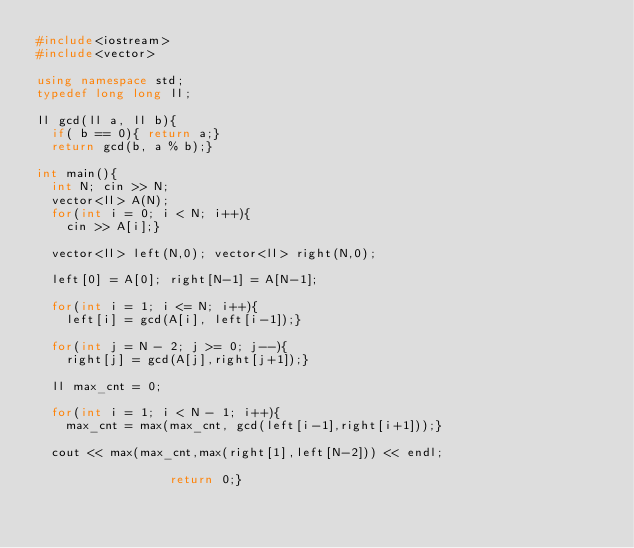Convert code to text. <code><loc_0><loc_0><loc_500><loc_500><_C++_>#include<iostream>
#include<vector>

using namespace std;
typedef long long ll;

ll gcd(ll a, ll b){
  if( b == 0){ return a;}
  return gcd(b, a % b);}

int main(){
  int N; cin >> N;
  vector<ll> A(N); 
  for(int i = 0; i < N; i++){
    cin >> A[i];}
  
  vector<ll> left(N,0); vector<ll> right(N,0);
  
  left[0] = A[0]; right[N-1] = A[N-1];
  
  for(int i = 1; i <= N; i++){
    left[i] = gcd(A[i], left[i-1]);}
  
  for(int j = N - 2; j >= 0; j--){
    right[j] = gcd(A[j],right[j+1]);}
  
  ll max_cnt = 0;
  
  for(int i = 1; i < N - 1; i++){
    max_cnt = max(max_cnt, gcd(left[i-1],right[i+1]));}
                  
  cout << max(max_cnt,max(right[1],left[N-2])) << endl;
                  
                  return 0;}
    


</code> 